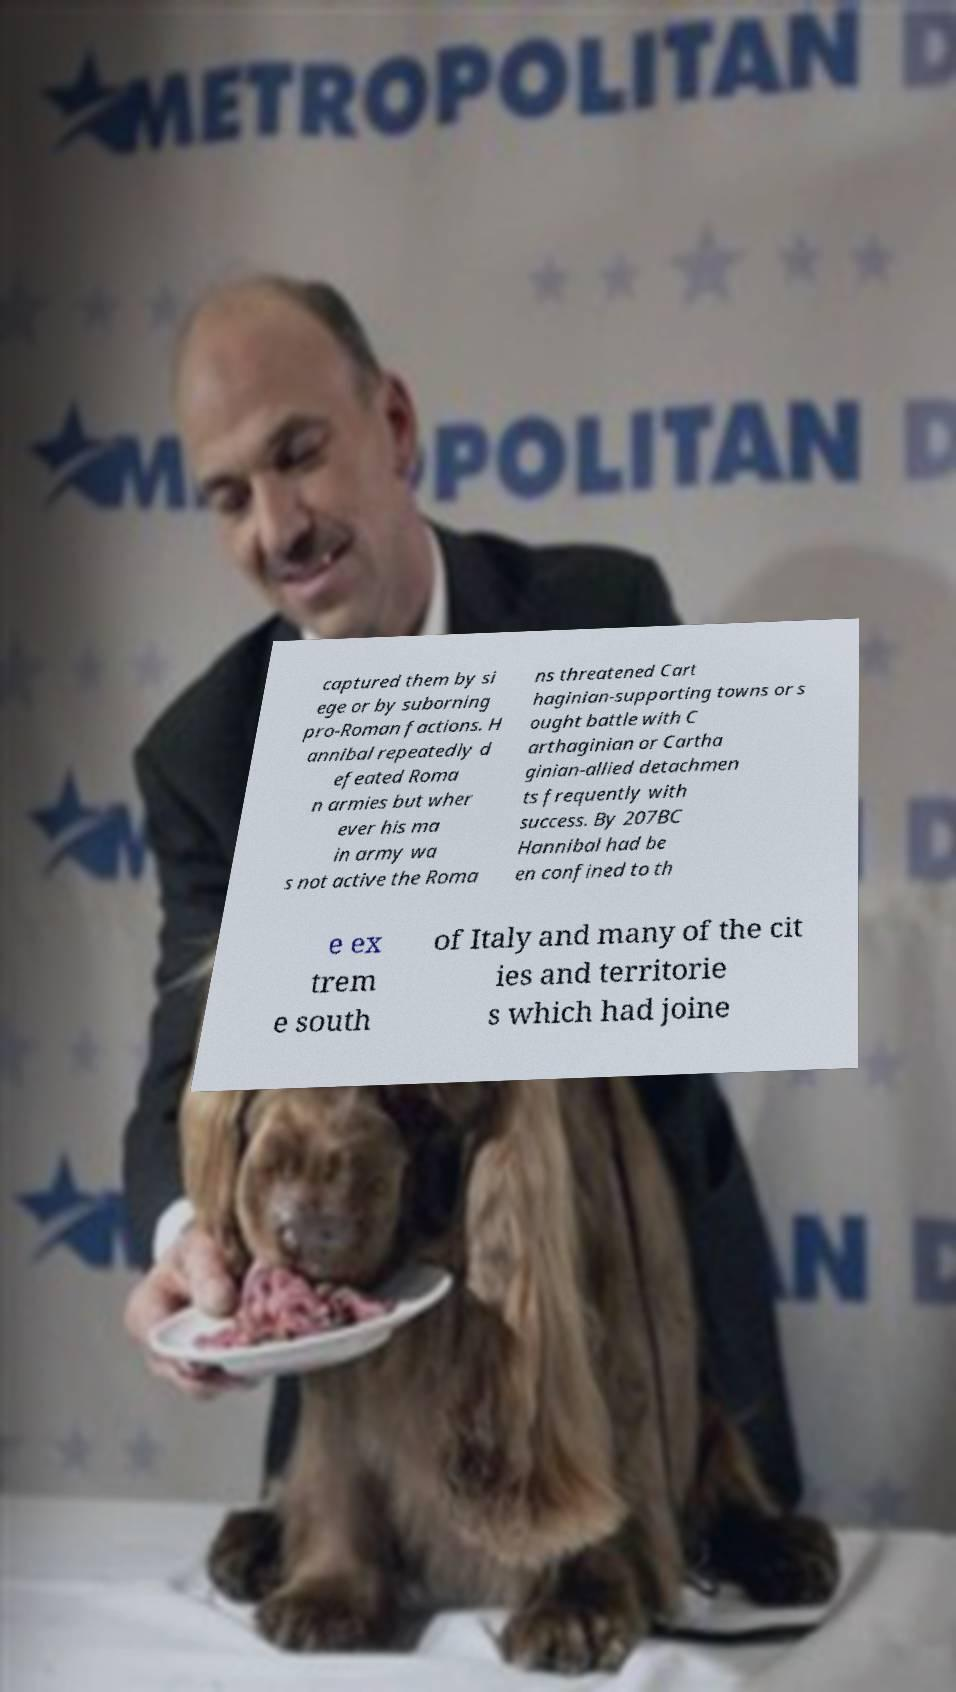Please read and relay the text visible in this image. What does it say? captured them by si ege or by suborning pro-Roman factions. H annibal repeatedly d efeated Roma n armies but wher ever his ma in army wa s not active the Roma ns threatened Cart haginian-supporting towns or s ought battle with C arthaginian or Cartha ginian-allied detachmen ts frequently with success. By 207BC Hannibal had be en confined to th e ex trem e south of Italy and many of the cit ies and territorie s which had joine 